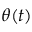<formula> <loc_0><loc_0><loc_500><loc_500>\theta ( t )</formula> 